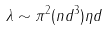Convert formula to latex. <formula><loc_0><loc_0><loc_500><loc_500>\lambda \sim \pi ^ { 2 } ( n d ^ { 3 } ) \eta d</formula> 